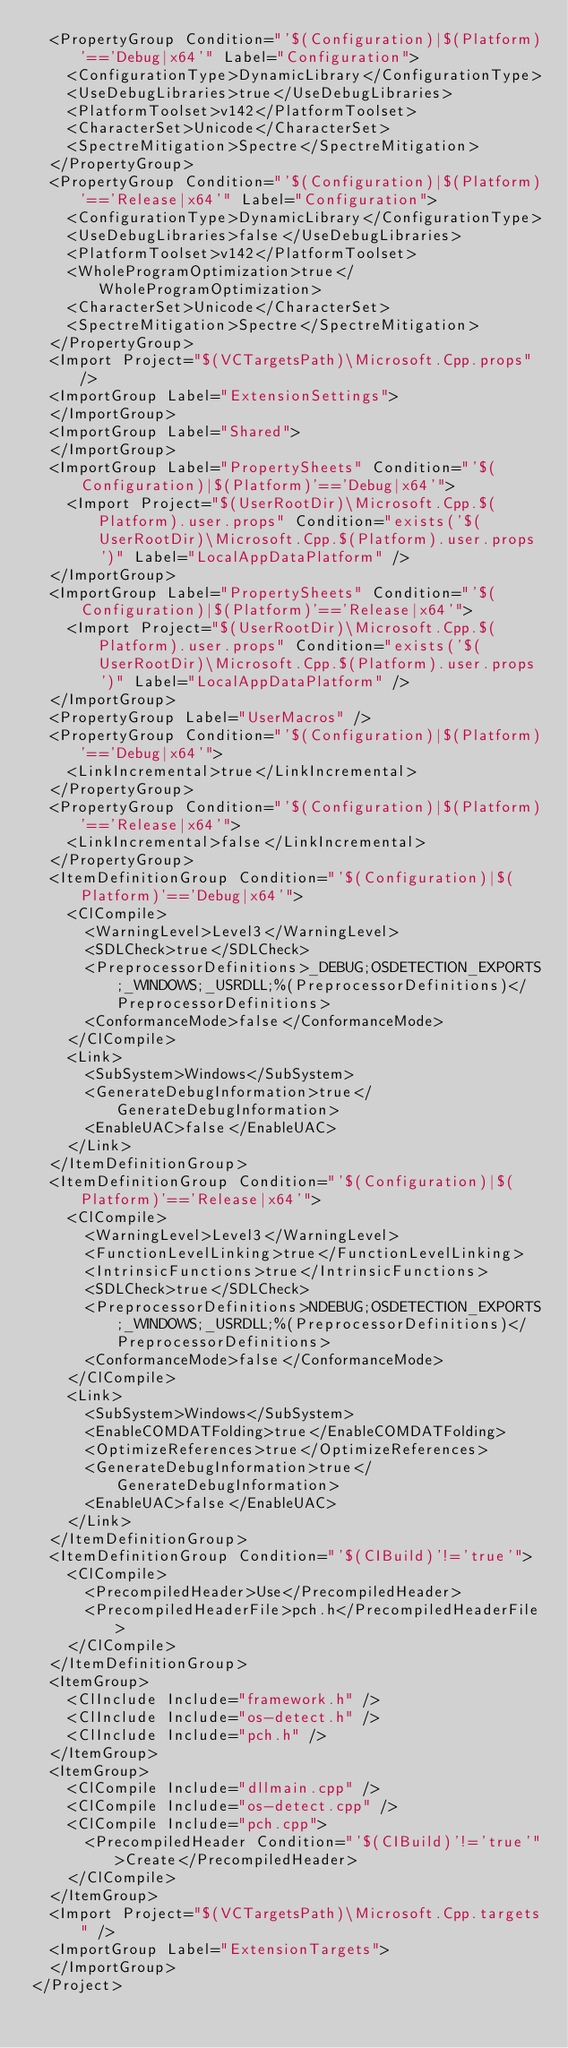Convert code to text. <code><loc_0><loc_0><loc_500><loc_500><_XML_>  <PropertyGroup Condition="'$(Configuration)|$(Platform)'=='Debug|x64'" Label="Configuration">
    <ConfigurationType>DynamicLibrary</ConfigurationType>
    <UseDebugLibraries>true</UseDebugLibraries>
    <PlatformToolset>v142</PlatformToolset>
    <CharacterSet>Unicode</CharacterSet>
    <SpectreMitigation>Spectre</SpectreMitigation>
  </PropertyGroup>
  <PropertyGroup Condition="'$(Configuration)|$(Platform)'=='Release|x64'" Label="Configuration">
    <ConfigurationType>DynamicLibrary</ConfigurationType>
    <UseDebugLibraries>false</UseDebugLibraries>
    <PlatformToolset>v142</PlatformToolset>
    <WholeProgramOptimization>true</WholeProgramOptimization>
    <CharacterSet>Unicode</CharacterSet>
    <SpectreMitigation>Spectre</SpectreMitigation>
  </PropertyGroup>
  <Import Project="$(VCTargetsPath)\Microsoft.Cpp.props" />
  <ImportGroup Label="ExtensionSettings">
  </ImportGroup>
  <ImportGroup Label="Shared">
  </ImportGroup>
  <ImportGroup Label="PropertySheets" Condition="'$(Configuration)|$(Platform)'=='Debug|x64'">
    <Import Project="$(UserRootDir)\Microsoft.Cpp.$(Platform).user.props" Condition="exists('$(UserRootDir)\Microsoft.Cpp.$(Platform).user.props')" Label="LocalAppDataPlatform" />
  </ImportGroup>
  <ImportGroup Label="PropertySheets" Condition="'$(Configuration)|$(Platform)'=='Release|x64'">
    <Import Project="$(UserRootDir)\Microsoft.Cpp.$(Platform).user.props" Condition="exists('$(UserRootDir)\Microsoft.Cpp.$(Platform).user.props')" Label="LocalAppDataPlatform" />
  </ImportGroup>
  <PropertyGroup Label="UserMacros" />
  <PropertyGroup Condition="'$(Configuration)|$(Platform)'=='Debug|x64'">
    <LinkIncremental>true</LinkIncremental>
  </PropertyGroup>
  <PropertyGroup Condition="'$(Configuration)|$(Platform)'=='Release|x64'">
    <LinkIncremental>false</LinkIncremental>
  </PropertyGroup>
  <ItemDefinitionGroup Condition="'$(Configuration)|$(Platform)'=='Debug|x64'">
    <ClCompile>
      <WarningLevel>Level3</WarningLevel>
      <SDLCheck>true</SDLCheck>
      <PreprocessorDefinitions>_DEBUG;OSDETECTION_EXPORTS;_WINDOWS;_USRDLL;%(PreprocessorDefinitions)</PreprocessorDefinitions>
      <ConformanceMode>false</ConformanceMode>
    </ClCompile>
    <Link>
      <SubSystem>Windows</SubSystem>
      <GenerateDebugInformation>true</GenerateDebugInformation>
      <EnableUAC>false</EnableUAC>
    </Link>
  </ItemDefinitionGroup>
  <ItemDefinitionGroup Condition="'$(Configuration)|$(Platform)'=='Release|x64'">
    <ClCompile>
      <WarningLevel>Level3</WarningLevel>
      <FunctionLevelLinking>true</FunctionLevelLinking>
      <IntrinsicFunctions>true</IntrinsicFunctions>
      <SDLCheck>true</SDLCheck>
      <PreprocessorDefinitions>NDEBUG;OSDETECTION_EXPORTS;_WINDOWS;_USRDLL;%(PreprocessorDefinitions)</PreprocessorDefinitions>
      <ConformanceMode>false</ConformanceMode>
    </ClCompile>
    <Link>
      <SubSystem>Windows</SubSystem>
      <EnableCOMDATFolding>true</EnableCOMDATFolding>
      <OptimizeReferences>true</OptimizeReferences>
      <GenerateDebugInformation>true</GenerateDebugInformation>
      <EnableUAC>false</EnableUAC>
    </Link>
  </ItemDefinitionGroup>
  <ItemDefinitionGroup Condition="'$(CIBuild)'!='true'">
    <ClCompile>
      <PrecompiledHeader>Use</PrecompiledHeader>
      <PrecompiledHeaderFile>pch.h</PrecompiledHeaderFile>
    </ClCompile>
  </ItemDefinitionGroup>
  <ItemGroup>
    <ClInclude Include="framework.h" />
    <ClInclude Include="os-detect.h" />
    <ClInclude Include="pch.h" />
  </ItemGroup>
  <ItemGroup>
    <ClCompile Include="dllmain.cpp" />
    <ClCompile Include="os-detect.cpp" />
    <ClCompile Include="pch.cpp">
      <PrecompiledHeader Condition="'$(CIBuild)'!='true'">Create</PrecompiledHeader>
    </ClCompile>
  </ItemGroup>
  <Import Project="$(VCTargetsPath)\Microsoft.Cpp.targets" />
  <ImportGroup Label="ExtensionTargets">
  </ImportGroup>
</Project></code> 